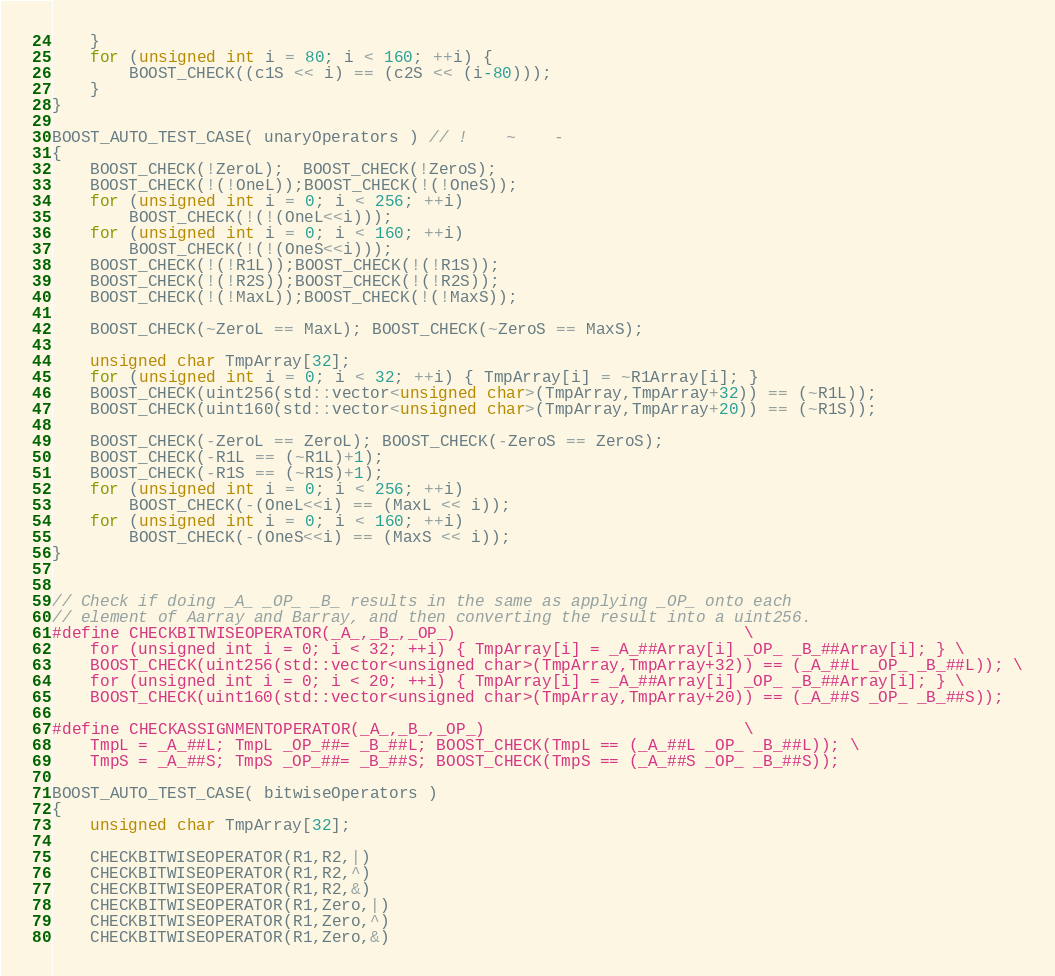<code> <loc_0><loc_0><loc_500><loc_500><_C++_>    }
    for (unsigned int i = 80; i < 160; ++i) {
        BOOST_CHECK((c1S << i) == (c2S << (i-80)));
    }
}

BOOST_AUTO_TEST_CASE( unaryOperators ) // !    ~    -
{
    BOOST_CHECK(!ZeroL);  BOOST_CHECK(!ZeroS);
    BOOST_CHECK(!(!OneL));BOOST_CHECK(!(!OneS));
    for (unsigned int i = 0; i < 256; ++i)
        BOOST_CHECK(!(!(OneL<<i)));
    for (unsigned int i = 0; i < 160; ++i)
        BOOST_CHECK(!(!(OneS<<i)));
    BOOST_CHECK(!(!R1L));BOOST_CHECK(!(!R1S));
    BOOST_CHECK(!(!R2S));BOOST_CHECK(!(!R2S));
    BOOST_CHECK(!(!MaxL));BOOST_CHECK(!(!MaxS));

    BOOST_CHECK(~ZeroL == MaxL); BOOST_CHECK(~ZeroS == MaxS);

    unsigned char TmpArray[32];
    for (unsigned int i = 0; i < 32; ++i) { TmpArray[i] = ~R1Array[i]; }
    BOOST_CHECK(uint256(std::vector<unsigned char>(TmpArray,TmpArray+32)) == (~R1L));
    BOOST_CHECK(uint160(std::vector<unsigned char>(TmpArray,TmpArray+20)) == (~R1S));

    BOOST_CHECK(-ZeroL == ZeroL); BOOST_CHECK(-ZeroS == ZeroS);
    BOOST_CHECK(-R1L == (~R1L)+1);
    BOOST_CHECK(-R1S == (~R1S)+1);
    for (unsigned int i = 0; i < 256; ++i)
        BOOST_CHECK(-(OneL<<i) == (MaxL << i));
    for (unsigned int i = 0; i < 160; ++i)
        BOOST_CHECK(-(OneS<<i) == (MaxS << i));
}


// Check if doing _A_ _OP_ _B_ results in the same as applying _OP_ onto each
// element of Aarray and Barray, and then converting the result into a uint256.
#define CHECKBITWISEOPERATOR(_A_,_B_,_OP_)                              \
    for (unsigned int i = 0; i < 32; ++i) { TmpArray[i] = _A_##Array[i] _OP_ _B_##Array[i]; } \
    BOOST_CHECK(uint256(std::vector<unsigned char>(TmpArray,TmpArray+32)) == (_A_##L _OP_ _B_##L)); \
    for (unsigned int i = 0; i < 20; ++i) { TmpArray[i] = _A_##Array[i] _OP_ _B_##Array[i]; } \
    BOOST_CHECK(uint160(std::vector<unsigned char>(TmpArray,TmpArray+20)) == (_A_##S _OP_ _B_##S));

#define CHECKASSIGNMENTOPERATOR(_A_,_B_,_OP_)                           \
    TmpL = _A_##L; TmpL _OP_##= _B_##L; BOOST_CHECK(TmpL == (_A_##L _OP_ _B_##L)); \
    TmpS = _A_##S; TmpS _OP_##= _B_##S; BOOST_CHECK(TmpS == (_A_##S _OP_ _B_##S));

BOOST_AUTO_TEST_CASE( bitwiseOperators )
{
    unsigned char TmpArray[32];

    CHECKBITWISEOPERATOR(R1,R2,|)
    CHECKBITWISEOPERATOR(R1,R2,^)
    CHECKBITWISEOPERATOR(R1,R2,&)
    CHECKBITWISEOPERATOR(R1,Zero,|)
    CHECKBITWISEOPERATOR(R1,Zero,^)
    CHECKBITWISEOPERATOR(R1,Zero,&)</code> 